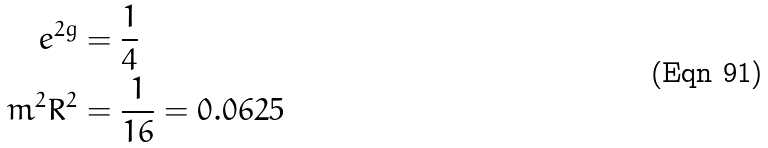<formula> <loc_0><loc_0><loc_500><loc_500>e ^ { 2 g } & = \frac { 1 } { 4 } \\ m ^ { 2 } R ^ { 2 } & = \frac { 1 } { 1 6 } = 0 . 0 6 2 5</formula> 